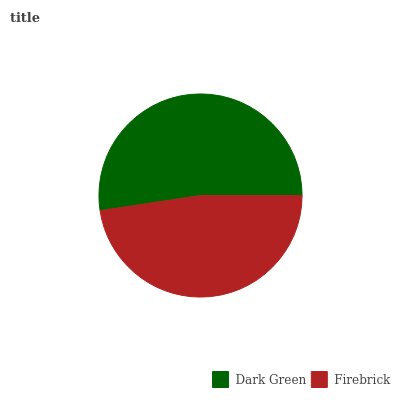Is Firebrick the minimum?
Answer yes or no. Yes. Is Dark Green the maximum?
Answer yes or no. Yes. Is Firebrick the maximum?
Answer yes or no. No. Is Dark Green greater than Firebrick?
Answer yes or no. Yes. Is Firebrick less than Dark Green?
Answer yes or no. Yes. Is Firebrick greater than Dark Green?
Answer yes or no. No. Is Dark Green less than Firebrick?
Answer yes or no. No. Is Dark Green the high median?
Answer yes or no. Yes. Is Firebrick the low median?
Answer yes or no. Yes. Is Firebrick the high median?
Answer yes or no. No. Is Dark Green the low median?
Answer yes or no. No. 